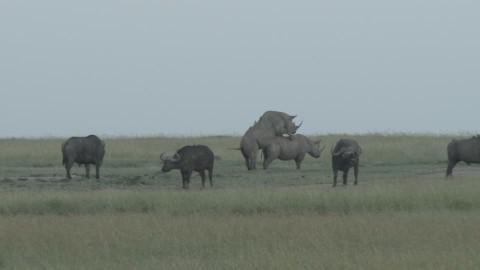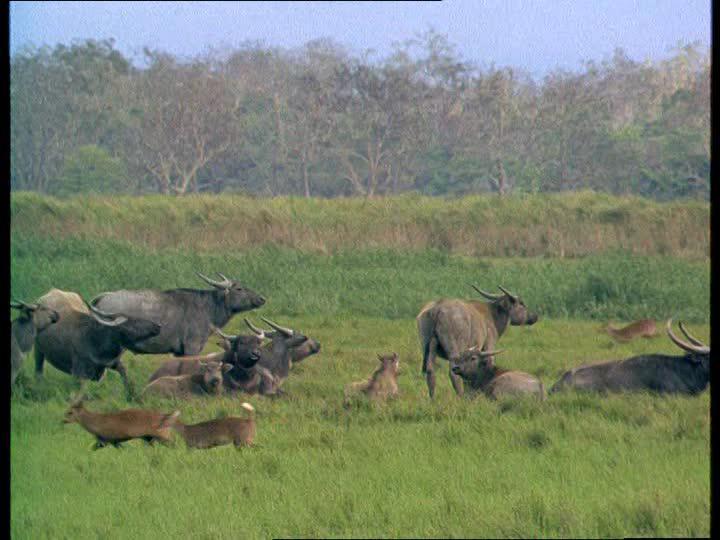The first image is the image on the left, the second image is the image on the right. Analyze the images presented: Is the assertion "The right image shows buffalo on a green field with no water visible, and the left image shows a body of water with at least some buffalo in it, and trees behind it." valid? Answer yes or no. No. The first image is the image on the left, the second image is the image on the right. Analyze the images presented: Is the assertion "There are at least 4 black ox in the water that is landlocked by grass." valid? Answer yes or no. No. 